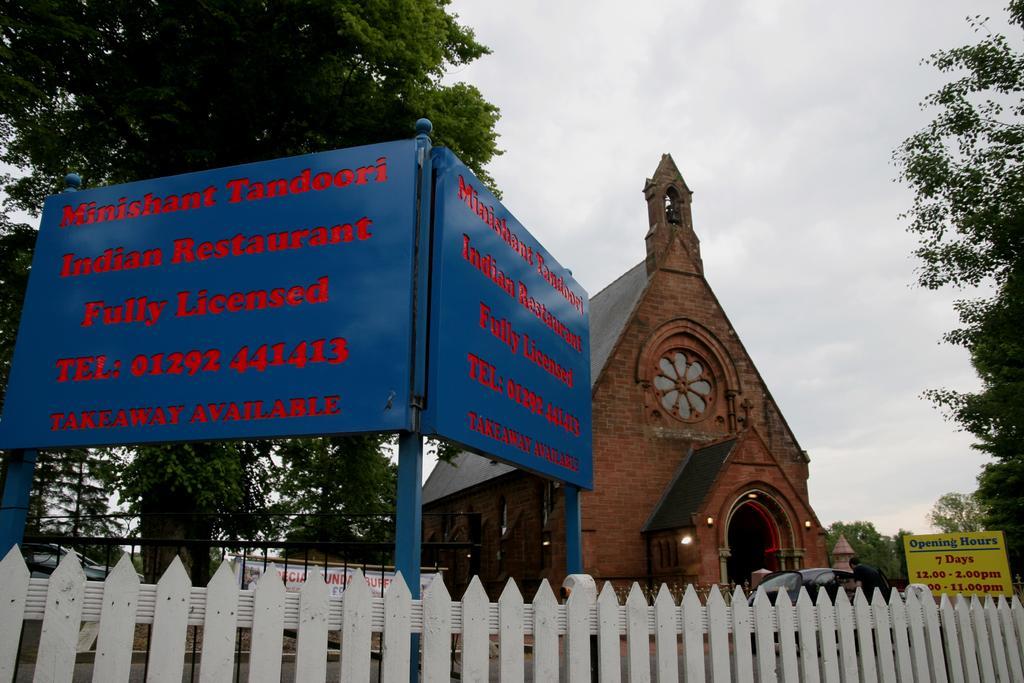Could you give a brief overview of what you see in this image? In this picture we can see fence, boards on poles and banner. There is a person and we can see cars, trees, lights and building. In the background of the image we can see the sky. 